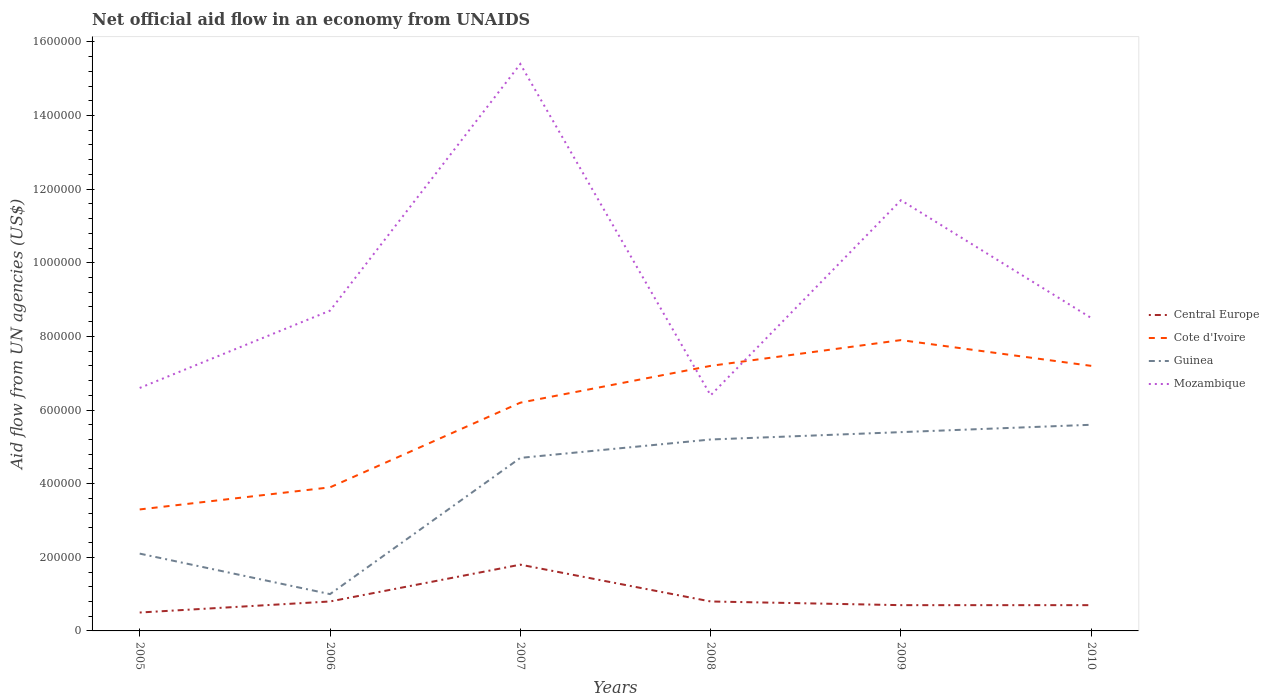Does the line corresponding to Central Europe intersect with the line corresponding to Guinea?
Your answer should be very brief. No. Is the number of lines equal to the number of legend labels?
Your answer should be very brief. Yes. Across all years, what is the maximum net official aid flow in Central Europe?
Your response must be concise. 5.00e+04. In which year was the net official aid flow in Central Europe maximum?
Your response must be concise. 2005. What is the total net official aid flow in Mozambique in the graph?
Your response must be concise. -2.10e+05. What is the difference between the highest and the second highest net official aid flow in Guinea?
Offer a very short reply. 4.60e+05. Is the net official aid flow in Guinea strictly greater than the net official aid flow in Mozambique over the years?
Your answer should be compact. Yes. What is the difference between two consecutive major ticks on the Y-axis?
Your answer should be compact. 2.00e+05. Does the graph contain any zero values?
Provide a succinct answer. No. What is the title of the graph?
Your answer should be compact. Net official aid flow in an economy from UNAIDS. Does "Tanzania" appear as one of the legend labels in the graph?
Provide a succinct answer. No. What is the label or title of the X-axis?
Give a very brief answer. Years. What is the label or title of the Y-axis?
Your answer should be very brief. Aid flow from UN agencies (US$). What is the Aid flow from UN agencies (US$) of Cote d'Ivoire in 2005?
Give a very brief answer. 3.30e+05. What is the Aid flow from UN agencies (US$) in Guinea in 2006?
Provide a short and direct response. 1.00e+05. What is the Aid flow from UN agencies (US$) in Mozambique in 2006?
Make the answer very short. 8.70e+05. What is the Aid flow from UN agencies (US$) of Central Europe in 2007?
Give a very brief answer. 1.80e+05. What is the Aid flow from UN agencies (US$) in Cote d'Ivoire in 2007?
Give a very brief answer. 6.20e+05. What is the Aid flow from UN agencies (US$) of Mozambique in 2007?
Your answer should be very brief. 1.54e+06. What is the Aid flow from UN agencies (US$) in Central Europe in 2008?
Give a very brief answer. 8.00e+04. What is the Aid flow from UN agencies (US$) in Cote d'Ivoire in 2008?
Ensure brevity in your answer.  7.20e+05. What is the Aid flow from UN agencies (US$) of Guinea in 2008?
Your response must be concise. 5.20e+05. What is the Aid flow from UN agencies (US$) in Mozambique in 2008?
Make the answer very short. 6.40e+05. What is the Aid flow from UN agencies (US$) of Cote d'Ivoire in 2009?
Keep it short and to the point. 7.90e+05. What is the Aid flow from UN agencies (US$) in Guinea in 2009?
Your answer should be very brief. 5.40e+05. What is the Aid flow from UN agencies (US$) of Mozambique in 2009?
Offer a terse response. 1.17e+06. What is the Aid flow from UN agencies (US$) in Central Europe in 2010?
Offer a very short reply. 7.00e+04. What is the Aid flow from UN agencies (US$) in Cote d'Ivoire in 2010?
Keep it short and to the point. 7.20e+05. What is the Aid flow from UN agencies (US$) in Guinea in 2010?
Offer a terse response. 5.60e+05. What is the Aid flow from UN agencies (US$) in Mozambique in 2010?
Provide a short and direct response. 8.50e+05. Across all years, what is the maximum Aid flow from UN agencies (US$) of Cote d'Ivoire?
Your response must be concise. 7.90e+05. Across all years, what is the maximum Aid flow from UN agencies (US$) of Guinea?
Your response must be concise. 5.60e+05. Across all years, what is the maximum Aid flow from UN agencies (US$) of Mozambique?
Give a very brief answer. 1.54e+06. Across all years, what is the minimum Aid flow from UN agencies (US$) in Central Europe?
Ensure brevity in your answer.  5.00e+04. Across all years, what is the minimum Aid flow from UN agencies (US$) of Guinea?
Give a very brief answer. 1.00e+05. Across all years, what is the minimum Aid flow from UN agencies (US$) of Mozambique?
Make the answer very short. 6.40e+05. What is the total Aid flow from UN agencies (US$) in Central Europe in the graph?
Your response must be concise. 5.30e+05. What is the total Aid flow from UN agencies (US$) in Cote d'Ivoire in the graph?
Give a very brief answer. 3.57e+06. What is the total Aid flow from UN agencies (US$) in Guinea in the graph?
Make the answer very short. 2.40e+06. What is the total Aid flow from UN agencies (US$) of Mozambique in the graph?
Offer a terse response. 5.73e+06. What is the difference between the Aid flow from UN agencies (US$) in Cote d'Ivoire in 2005 and that in 2006?
Make the answer very short. -6.00e+04. What is the difference between the Aid flow from UN agencies (US$) of Mozambique in 2005 and that in 2006?
Provide a short and direct response. -2.10e+05. What is the difference between the Aid flow from UN agencies (US$) in Cote d'Ivoire in 2005 and that in 2007?
Offer a very short reply. -2.90e+05. What is the difference between the Aid flow from UN agencies (US$) in Guinea in 2005 and that in 2007?
Offer a terse response. -2.60e+05. What is the difference between the Aid flow from UN agencies (US$) of Mozambique in 2005 and that in 2007?
Your answer should be very brief. -8.80e+05. What is the difference between the Aid flow from UN agencies (US$) in Cote d'Ivoire in 2005 and that in 2008?
Your answer should be very brief. -3.90e+05. What is the difference between the Aid flow from UN agencies (US$) of Guinea in 2005 and that in 2008?
Make the answer very short. -3.10e+05. What is the difference between the Aid flow from UN agencies (US$) of Mozambique in 2005 and that in 2008?
Your answer should be very brief. 2.00e+04. What is the difference between the Aid flow from UN agencies (US$) in Central Europe in 2005 and that in 2009?
Your response must be concise. -2.00e+04. What is the difference between the Aid flow from UN agencies (US$) in Cote d'Ivoire in 2005 and that in 2009?
Your answer should be very brief. -4.60e+05. What is the difference between the Aid flow from UN agencies (US$) of Guinea in 2005 and that in 2009?
Your response must be concise. -3.30e+05. What is the difference between the Aid flow from UN agencies (US$) in Mozambique in 2005 and that in 2009?
Your answer should be compact. -5.10e+05. What is the difference between the Aid flow from UN agencies (US$) in Central Europe in 2005 and that in 2010?
Make the answer very short. -2.00e+04. What is the difference between the Aid flow from UN agencies (US$) of Cote d'Ivoire in 2005 and that in 2010?
Your answer should be compact. -3.90e+05. What is the difference between the Aid flow from UN agencies (US$) in Guinea in 2005 and that in 2010?
Make the answer very short. -3.50e+05. What is the difference between the Aid flow from UN agencies (US$) of Mozambique in 2005 and that in 2010?
Your response must be concise. -1.90e+05. What is the difference between the Aid flow from UN agencies (US$) in Central Europe in 2006 and that in 2007?
Provide a succinct answer. -1.00e+05. What is the difference between the Aid flow from UN agencies (US$) of Guinea in 2006 and that in 2007?
Ensure brevity in your answer.  -3.70e+05. What is the difference between the Aid flow from UN agencies (US$) of Mozambique in 2006 and that in 2007?
Provide a succinct answer. -6.70e+05. What is the difference between the Aid flow from UN agencies (US$) of Central Europe in 2006 and that in 2008?
Offer a terse response. 0. What is the difference between the Aid flow from UN agencies (US$) in Cote d'Ivoire in 2006 and that in 2008?
Ensure brevity in your answer.  -3.30e+05. What is the difference between the Aid flow from UN agencies (US$) in Guinea in 2006 and that in 2008?
Offer a very short reply. -4.20e+05. What is the difference between the Aid flow from UN agencies (US$) of Mozambique in 2006 and that in 2008?
Make the answer very short. 2.30e+05. What is the difference between the Aid flow from UN agencies (US$) of Central Europe in 2006 and that in 2009?
Ensure brevity in your answer.  10000. What is the difference between the Aid flow from UN agencies (US$) in Cote d'Ivoire in 2006 and that in 2009?
Ensure brevity in your answer.  -4.00e+05. What is the difference between the Aid flow from UN agencies (US$) of Guinea in 2006 and that in 2009?
Make the answer very short. -4.40e+05. What is the difference between the Aid flow from UN agencies (US$) of Mozambique in 2006 and that in 2009?
Keep it short and to the point. -3.00e+05. What is the difference between the Aid flow from UN agencies (US$) in Cote d'Ivoire in 2006 and that in 2010?
Your response must be concise. -3.30e+05. What is the difference between the Aid flow from UN agencies (US$) in Guinea in 2006 and that in 2010?
Provide a succinct answer. -4.60e+05. What is the difference between the Aid flow from UN agencies (US$) in Central Europe in 2007 and that in 2008?
Give a very brief answer. 1.00e+05. What is the difference between the Aid flow from UN agencies (US$) in Guinea in 2007 and that in 2008?
Provide a short and direct response. -5.00e+04. What is the difference between the Aid flow from UN agencies (US$) in Mozambique in 2007 and that in 2008?
Your answer should be compact. 9.00e+05. What is the difference between the Aid flow from UN agencies (US$) of Cote d'Ivoire in 2007 and that in 2009?
Provide a short and direct response. -1.70e+05. What is the difference between the Aid flow from UN agencies (US$) in Guinea in 2007 and that in 2009?
Give a very brief answer. -7.00e+04. What is the difference between the Aid flow from UN agencies (US$) in Central Europe in 2007 and that in 2010?
Provide a succinct answer. 1.10e+05. What is the difference between the Aid flow from UN agencies (US$) of Cote d'Ivoire in 2007 and that in 2010?
Your answer should be compact. -1.00e+05. What is the difference between the Aid flow from UN agencies (US$) in Guinea in 2007 and that in 2010?
Keep it short and to the point. -9.00e+04. What is the difference between the Aid flow from UN agencies (US$) of Mozambique in 2007 and that in 2010?
Ensure brevity in your answer.  6.90e+05. What is the difference between the Aid flow from UN agencies (US$) of Central Europe in 2008 and that in 2009?
Provide a short and direct response. 10000. What is the difference between the Aid flow from UN agencies (US$) in Cote d'Ivoire in 2008 and that in 2009?
Give a very brief answer. -7.00e+04. What is the difference between the Aid flow from UN agencies (US$) in Mozambique in 2008 and that in 2009?
Your response must be concise. -5.30e+05. What is the difference between the Aid flow from UN agencies (US$) of Central Europe in 2009 and that in 2010?
Keep it short and to the point. 0. What is the difference between the Aid flow from UN agencies (US$) of Cote d'Ivoire in 2009 and that in 2010?
Offer a terse response. 7.00e+04. What is the difference between the Aid flow from UN agencies (US$) in Guinea in 2009 and that in 2010?
Give a very brief answer. -2.00e+04. What is the difference between the Aid flow from UN agencies (US$) in Central Europe in 2005 and the Aid flow from UN agencies (US$) in Cote d'Ivoire in 2006?
Provide a short and direct response. -3.40e+05. What is the difference between the Aid flow from UN agencies (US$) of Central Europe in 2005 and the Aid flow from UN agencies (US$) of Mozambique in 2006?
Your answer should be very brief. -8.20e+05. What is the difference between the Aid flow from UN agencies (US$) of Cote d'Ivoire in 2005 and the Aid flow from UN agencies (US$) of Guinea in 2006?
Your response must be concise. 2.30e+05. What is the difference between the Aid flow from UN agencies (US$) in Cote d'Ivoire in 2005 and the Aid flow from UN agencies (US$) in Mozambique in 2006?
Provide a succinct answer. -5.40e+05. What is the difference between the Aid flow from UN agencies (US$) of Guinea in 2005 and the Aid flow from UN agencies (US$) of Mozambique in 2006?
Offer a terse response. -6.60e+05. What is the difference between the Aid flow from UN agencies (US$) of Central Europe in 2005 and the Aid flow from UN agencies (US$) of Cote d'Ivoire in 2007?
Your answer should be compact. -5.70e+05. What is the difference between the Aid flow from UN agencies (US$) of Central Europe in 2005 and the Aid flow from UN agencies (US$) of Guinea in 2007?
Offer a very short reply. -4.20e+05. What is the difference between the Aid flow from UN agencies (US$) in Central Europe in 2005 and the Aid flow from UN agencies (US$) in Mozambique in 2007?
Provide a short and direct response. -1.49e+06. What is the difference between the Aid flow from UN agencies (US$) in Cote d'Ivoire in 2005 and the Aid flow from UN agencies (US$) in Mozambique in 2007?
Your answer should be very brief. -1.21e+06. What is the difference between the Aid flow from UN agencies (US$) in Guinea in 2005 and the Aid flow from UN agencies (US$) in Mozambique in 2007?
Your response must be concise. -1.33e+06. What is the difference between the Aid flow from UN agencies (US$) of Central Europe in 2005 and the Aid flow from UN agencies (US$) of Cote d'Ivoire in 2008?
Offer a very short reply. -6.70e+05. What is the difference between the Aid flow from UN agencies (US$) of Central Europe in 2005 and the Aid flow from UN agencies (US$) of Guinea in 2008?
Ensure brevity in your answer.  -4.70e+05. What is the difference between the Aid flow from UN agencies (US$) in Central Europe in 2005 and the Aid flow from UN agencies (US$) in Mozambique in 2008?
Give a very brief answer. -5.90e+05. What is the difference between the Aid flow from UN agencies (US$) in Cote d'Ivoire in 2005 and the Aid flow from UN agencies (US$) in Guinea in 2008?
Keep it short and to the point. -1.90e+05. What is the difference between the Aid flow from UN agencies (US$) of Cote d'Ivoire in 2005 and the Aid flow from UN agencies (US$) of Mozambique in 2008?
Ensure brevity in your answer.  -3.10e+05. What is the difference between the Aid flow from UN agencies (US$) of Guinea in 2005 and the Aid flow from UN agencies (US$) of Mozambique in 2008?
Provide a succinct answer. -4.30e+05. What is the difference between the Aid flow from UN agencies (US$) in Central Europe in 2005 and the Aid flow from UN agencies (US$) in Cote d'Ivoire in 2009?
Your answer should be very brief. -7.40e+05. What is the difference between the Aid flow from UN agencies (US$) in Central Europe in 2005 and the Aid flow from UN agencies (US$) in Guinea in 2009?
Your response must be concise. -4.90e+05. What is the difference between the Aid flow from UN agencies (US$) in Central Europe in 2005 and the Aid flow from UN agencies (US$) in Mozambique in 2009?
Offer a terse response. -1.12e+06. What is the difference between the Aid flow from UN agencies (US$) of Cote d'Ivoire in 2005 and the Aid flow from UN agencies (US$) of Guinea in 2009?
Make the answer very short. -2.10e+05. What is the difference between the Aid flow from UN agencies (US$) in Cote d'Ivoire in 2005 and the Aid flow from UN agencies (US$) in Mozambique in 2009?
Give a very brief answer. -8.40e+05. What is the difference between the Aid flow from UN agencies (US$) in Guinea in 2005 and the Aid flow from UN agencies (US$) in Mozambique in 2009?
Offer a terse response. -9.60e+05. What is the difference between the Aid flow from UN agencies (US$) in Central Europe in 2005 and the Aid flow from UN agencies (US$) in Cote d'Ivoire in 2010?
Give a very brief answer. -6.70e+05. What is the difference between the Aid flow from UN agencies (US$) in Central Europe in 2005 and the Aid flow from UN agencies (US$) in Guinea in 2010?
Your response must be concise. -5.10e+05. What is the difference between the Aid flow from UN agencies (US$) of Central Europe in 2005 and the Aid flow from UN agencies (US$) of Mozambique in 2010?
Make the answer very short. -8.00e+05. What is the difference between the Aid flow from UN agencies (US$) in Cote d'Ivoire in 2005 and the Aid flow from UN agencies (US$) in Guinea in 2010?
Your answer should be very brief. -2.30e+05. What is the difference between the Aid flow from UN agencies (US$) of Cote d'Ivoire in 2005 and the Aid flow from UN agencies (US$) of Mozambique in 2010?
Give a very brief answer. -5.20e+05. What is the difference between the Aid flow from UN agencies (US$) of Guinea in 2005 and the Aid flow from UN agencies (US$) of Mozambique in 2010?
Ensure brevity in your answer.  -6.40e+05. What is the difference between the Aid flow from UN agencies (US$) of Central Europe in 2006 and the Aid flow from UN agencies (US$) of Cote d'Ivoire in 2007?
Ensure brevity in your answer.  -5.40e+05. What is the difference between the Aid flow from UN agencies (US$) in Central Europe in 2006 and the Aid flow from UN agencies (US$) in Guinea in 2007?
Your answer should be compact. -3.90e+05. What is the difference between the Aid flow from UN agencies (US$) of Central Europe in 2006 and the Aid flow from UN agencies (US$) of Mozambique in 2007?
Offer a very short reply. -1.46e+06. What is the difference between the Aid flow from UN agencies (US$) in Cote d'Ivoire in 2006 and the Aid flow from UN agencies (US$) in Guinea in 2007?
Your response must be concise. -8.00e+04. What is the difference between the Aid flow from UN agencies (US$) of Cote d'Ivoire in 2006 and the Aid flow from UN agencies (US$) of Mozambique in 2007?
Your answer should be compact. -1.15e+06. What is the difference between the Aid flow from UN agencies (US$) of Guinea in 2006 and the Aid flow from UN agencies (US$) of Mozambique in 2007?
Offer a terse response. -1.44e+06. What is the difference between the Aid flow from UN agencies (US$) of Central Europe in 2006 and the Aid flow from UN agencies (US$) of Cote d'Ivoire in 2008?
Offer a very short reply. -6.40e+05. What is the difference between the Aid flow from UN agencies (US$) in Central Europe in 2006 and the Aid flow from UN agencies (US$) in Guinea in 2008?
Your answer should be very brief. -4.40e+05. What is the difference between the Aid flow from UN agencies (US$) in Central Europe in 2006 and the Aid flow from UN agencies (US$) in Mozambique in 2008?
Provide a short and direct response. -5.60e+05. What is the difference between the Aid flow from UN agencies (US$) of Cote d'Ivoire in 2006 and the Aid flow from UN agencies (US$) of Guinea in 2008?
Your response must be concise. -1.30e+05. What is the difference between the Aid flow from UN agencies (US$) of Cote d'Ivoire in 2006 and the Aid flow from UN agencies (US$) of Mozambique in 2008?
Give a very brief answer. -2.50e+05. What is the difference between the Aid flow from UN agencies (US$) of Guinea in 2006 and the Aid flow from UN agencies (US$) of Mozambique in 2008?
Keep it short and to the point. -5.40e+05. What is the difference between the Aid flow from UN agencies (US$) of Central Europe in 2006 and the Aid flow from UN agencies (US$) of Cote d'Ivoire in 2009?
Provide a succinct answer. -7.10e+05. What is the difference between the Aid flow from UN agencies (US$) in Central Europe in 2006 and the Aid flow from UN agencies (US$) in Guinea in 2009?
Ensure brevity in your answer.  -4.60e+05. What is the difference between the Aid flow from UN agencies (US$) in Central Europe in 2006 and the Aid flow from UN agencies (US$) in Mozambique in 2009?
Provide a short and direct response. -1.09e+06. What is the difference between the Aid flow from UN agencies (US$) in Cote d'Ivoire in 2006 and the Aid flow from UN agencies (US$) in Mozambique in 2009?
Provide a succinct answer. -7.80e+05. What is the difference between the Aid flow from UN agencies (US$) of Guinea in 2006 and the Aid flow from UN agencies (US$) of Mozambique in 2009?
Keep it short and to the point. -1.07e+06. What is the difference between the Aid flow from UN agencies (US$) in Central Europe in 2006 and the Aid flow from UN agencies (US$) in Cote d'Ivoire in 2010?
Provide a succinct answer. -6.40e+05. What is the difference between the Aid flow from UN agencies (US$) of Central Europe in 2006 and the Aid flow from UN agencies (US$) of Guinea in 2010?
Your answer should be very brief. -4.80e+05. What is the difference between the Aid flow from UN agencies (US$) in Central Europe in 2006 and the Aid flow from UN agencies (US$) in Mozambique in 2010?
Provide a succinct answer. -7.70e+05. What is the difference between the Aid flow from UN agencies (US$) in Cote d'Ivoire in 2006 and the Aid flow from UN agencies (US$) in Mozambique in 2010?
Keep it short and to the point. -4.60e+05. What is the difference between the Aid flow from UN agencies (US$) of Guinea in 2006 and the Aid flow from UN agencies (US$) of Mozambique in 2010?
Provide a short and direct response. -7.50e+05. What is the difference between the Aid flow from UN agencies (US$) of Central Europe in 2007 and the Aid flow from UN agencies (US$) of Cote d'Ivoire in 2008?
Your answer should be compact. -5.40e+05. What is the difference between the Aid flow from UN agencies (US$) in Central Europe in 2007 and the Aid flow from UN agencies (US$) in Mozambique in 2008?
Make the answer very short. -4.60e+05. What is the difference between the Aid flow from UN agencies (US$) in Cote d'Ivoire in 2007 and the Aid flow from UN agencies (US$) in Guinea in 2008?
Provide a succinct answer. 1.00e+05. What is the difference between the Aid flow from UN agencies (US$) in Cote d'Ivoire in 2007 and the Aid flow from UN agencies (US$) in Mozambique in 2008?
Make the answer very short. -2.00e+04. What is the difference between the Aid flow from UN agencies (US$) in Central Europe in 2007 and the Aid flow from UN agencies (US$) in Cote d'Ivoire in 2009?
Provide a short and direct response. -6.10e+05. What is the difference between the Aid flow from UN agencies (US$) in Central Europe in 2007 and the Aid flow from UN agencies (US$) in Guinea in 2009?
Give a very brief answer. -3.60e+05. What is the difference between the Aid flow from UN agencies (US$) in Central Europe in 2007 and the Aid flow from UN agencies (US$) in Mozambique in 2009?
Offer a very short reply. -9.90e+05. What is the difference between the Aid flow from UN agencies (US$) in Cote d'Ivoire in 2007 and the Aid flow from UN agencies (US$) in Guinea in 2009?
Offer a very short reply. 8.00e+04. What is the difference between the Aid flow from UN agencies (US$) in Cote d'Ivoire in 2007 and the Aid flow from UN agencies (US$) in Mozambique in 2009?
Offer a very short reply. -5.50e+05. What is the difference between the Aid flow from UN agencies (US$) of Guinea in 2007 and the Aid flow from UN agencies (US$) of Mozambique in 2009?
Provide a succinct answer. -7.00e+05. What is the difference between the Aid flow from UN agencies (US$) of Central Europe in 2007 and the Aid flow from UN agencies (US$) of Cote d'Ivoire in 2010?
Keep it short and to the point. -5.40e+05. What is the difference between the Aid flow from UN agencies (US$) of Central Europe in 2007 and the Aid flow from UN agencies (US$) of Guinea in 2010?
Offer a terse response. -3.80e+05. What is the difference between the Aid flow from UN agencies (US$) in Central Europe in 2007 and the Aid flow from UN agencies (US$) in Mozambique in 2010?
Your answer should be compact. -6.70e+05. What is the difference between the Aid flow from UN agencies (US$) of Cote d'Ivoire in 2007 and the Aid flow from UN agencies (US$) of Guinea in 2010?
Provide a succinct answer. 6.00e+04. What is the difference between the Aid flow from UN agencies (US$) in Cote d'Ivoire in 2007 and the Aid flow from UN agencies (US$) in Mozambique in 2010?
Provide a short and direct response. -2.30e+05. What is the difference between the Aid flow from UN agencies (US$) in Guinea in 2007 and the Aid flow from UN agencies (US$) in Mozambique in 2010?
Offer a very short reply. -3.80e+05. What is the difference between the Aid flow from UN agencies (US$) in Central Europe in 2008 and the Aid flow from UN agencies (US$) in Cote d'Ivoire in 2009?
Provide a short and direct response. -7.10e+05. What is the difference between the Aid flow from UN agencies (US$) in Central Europe in 2008 and the Aid flow from UN agencies (US$) in Guinea in 2009?
Provide a succinct answer. -4.60e+05. What is the difference between the Aid flow from UN agencies (US$) in Central Europe in 2008 and the Aid flow from UN agencies (US$) in Mozambique in 2009?
Offer a very short reply. -1.09e+06. What is the difference between the Aid flow from UN agencies (US$) in Cote d'Ivoire in 2008 and the Aid flow from UN agencies (US$) in Guinea in 2009?
Offer a terse response. 1.80e+05. What is the difference between the Aid flow from UN agencies (US$) in Cote d'Ivoire in 2008 and the Aid flow from UN agencies (US$) in Mozambique in 2009?
Provide a succinct answer. -4.50e+05. What is the difference between the Aid flow from UN agencies (US$) of Guinea in 2008 and the Aid flow from UN agencies (US$) of Mozambique in 2009?
Provide a succinct answer. -6.50e+05. What is the difference between the Aid flow from UN agencies (US$) in Central Europe in 2008 and the Aid flow from UN agencies (US$) in Cote d'Ivoire in 2010?
Provide a succinct answer. -6.40e+05. What is the difference between the Aid flow from UN agencies (US$) of Central Europe in 2008 and the Aid flow from UN agencies (US$) of Guinea in 2010?
Your response must be concise. -4.80e+05. What is the difference between the Aid flow from UN agencies (US$) in Central Europe in 2008 and the Aid flow from UN agencies (US$) in Mozambique in 2010?
Provide a short and direct response. -7.70e+05. What is the difference between the Aid flow from UN agencies (US$) in Cote d'Ivoire in 2008 and the Aid flow from UN agencies (US$) in Guinea in 2010?
Provide a succinct answer. 1.60e+05. What is the difference between the Aid flow from UN agencies (US$) in Guinea in 2008 and the Aid flow from UN agencies (US$) in Mozambique in 2010?
Offer a terse response. -3.30e+05. What is the difference between the Aid flow from UN agencies (US$) of Central Europe in 2009 and the Aid flow from UN agencies (US$) of Cote d'Ivoire in 2010?
Keep it short and to the point. -6.50e+05. What is the difference between the Aid flow from UN agencies (US$) in Central Europe in 2009 and the Aid flow from UN agencies (US$) in Guinea in 2010?
Make the answer very short. -4.90e+05. What is the difference between the Aid flow from UN agencies (US$) in Central Europe in 2009 and the Aid flow from UN agencies (US$) in Mozambique in 2010?
Your response must be concise. -7.80e+05. What is the difference between the Aid flow from UN agencies (US$) in Cote d'Ivoire in 2009 and the Aid flow from UN agencies (US$) in Guinea in 2010?
Provide a succinct answer. 2.30e+05. What is the difference between the Aid flow from UN agencies (US$) in Cote d'Ivoire in 2009 and the Aid flow from UN agencies (US$) in Mozambique in 2010?
Your response must be concise. -6.00e+04. What is the difference between the Aid flow from UN agencies (US$) in Guinea in 2009 and the Aid flow from UN agencies (US$) in Mozambique in 2010?
Offer a terse response. -3.10e+05. What is the average Aid flow from UN agencies (US$) of Central Europe per year?
Your answer should be compact. 8.83e+04. What is the average Aid flow from UN agencies (US$) in Cote d'Ivoire per year?
Ensure brevity in your answer.  5.95e+05. What is the average Aid flow from UN agencies (US$) in Guinea per year?
Offer a very short reply. 4.00e+05. What is the average Aid flow from UN agencies (US$) of Mozambique per year?
Your answer should be very brief. 9.55e+05. In the year 2005, what is the difference between the Aid flow from UN agencies (US$) in Central Europe and Aid flow from UN agencies (US$) in Cote d'Ivoire?
Give a very brief answer. -2.80e+05. In the year 2005, what is the difference between the Aid flow from UN agencies (US$) in Central Europe and Aid flow from UN agencies (US$) in Guinea?
Offer a very short reply. -1.60e+05. In the year 2005, what is the difference between the Aid flow from UN agencies (US$) of Central Europe and Aid flow from UN agencies (US$) of Mozambique?
Offer a very short reply. -6.10e+05. In the year 2005, what is the difference between the Aid flow from UN agencies (US$) of Cote d'Ivoire and Aid flow from UN agencies (US$) of Guinea?
Give a very brief answer. 1.20e+05. In the year 2005, what is the difference between the Aid flow from UN agencies (US$) in Cote d'Ivoire and Aid flow from UN agencies (US$) in Mozambique?
Make the answer very short. -3.30e+05. In the year 2005, what is the difference between the Aid flow from UN agencies (US$) in Guinea and Aid flow from UN agencies (US$) in Mozambique?
Ensure brevity in your answer.  -4.50e+05. In the year 2006, what is the difference between the Aid flow from UN agencies (US$) in Central Europe and Aid flow from UN agencies (US$) in Cote d'Ivoire?
Your answer should be very brief. -3.10e+05. In the year 2006, what is the difference between the Aid flow from UN agencies (US$) of Central Europe and Aid flow from UN agencies (US$) of Guinea?
Make the answer very short. -2.00e+04. In the year 2006, what is the difference between the Aid flow from UN agencies (US$) in Central Europe and Aid flow from UN agencies (US$) in Mozambique?
Make the answer very short. -7.90e+05. In the year 2006, what is the difference between the Aid flow from UN agencies (US$) in Cote d'Ivoire and Aid flow from UN agencies (US$) in Mozambique?
Your answer should be compact. -4.80e+05. In the year 2006, what is the difference between the Aid flow from UN agencies (US$) of Guinea and Aid flow from UN agencies (US$) of Mozambique?
Provide a short and direct response. -7.70e+05. In the year 2007, what is the difference between the Aid flow from UN agencies (US$) of Central Europe and Aid flow from UN agencies (US$) of Cote d'Ivoire?
Make the answer very short. -4.40e+05. In the year 2007, what is the difference between the Aid flow from UN agencies (US$) in Central Europe and Aid flow from UN agencies (US$) in Mozambique?
Your answer should be compact. -1.36e+06. In the year 2007, what is the difference between the Aid flow from UN agencies (US$) in Cote d'Ivoire and Aid flow from UN agencies (US$) in Guinea?
Offer a very short reply. 1.50e+05. In the year 2007, what is the difference between the Aid flow from UN agencies (US$) in Cote d'Ivoire and Aid flow from UN agencies (US$) in Mozambique?
Make the answer very short. -9.20e+05. In the year 2007, what is the difference between the Aid flow from UN agencies (US$) in Guinea and Aid flow from UN agencies (US$) in Mozambique?
Keep it short and to the point. -1.07e+06. In the year 2008, what is the difference between the Aid flow from UN agencies (US$) of Central Europe and Aid flow from UN agencies (US$) of Cote d'Ivoire?
Keep it short and to the point. -6.40e+05. In the year 2008, what is the difference between the Aid flow from UN agencies (US$) in Central Europe and Aid flow from UN agencies (US$) in Guinea?
Provide a short and direct response. -4.40e+05. In the year 2008, what is the difference between the Aid flow from UN agencies (US$) in Central Europe and Aid flow from UN agencies (US$) in Mozambique?
Your answer should be very brief. -5.60e+05. In the year 2008, what is the difference between the Aid flow from UN agencies (US$) of Guinea and Aid flow from UN agencies (US$) of Mozambique?
Ensure brevity in your answer.  -1.20e+05. In the year 2009, what is the difference between the Aid flow from UN agencies (US$) of Central Europe and Aid flow from UN agencies (US$) of Cote d'Ivoire?
Offer a terse response. -7.20e+05. In the year 2009, what is the difference between the Aid flow from UN agencies (US$) in Central Europe and Aid flow from UN agencies (US$) in Guinea?
Your answer should be compact. -4.70e+05. In the year 2009, what is the difference between the Aid flow from UN agencies (US$) in Central Europe and Aid flow from UN agencies (US$) in Mozambique?
Give a very brief answer. -1.10e+06. In the year 2009, what is the difference between the Aid flow from UN agencies (US$) in Cote d'Ivoire and Aid flow from UN agencies (US$) in Guinea?
Your answer should be compact. 2.50e+05. In the year 2009, what is the difference between the Aid flow from UN agencies (US$) of Cote d'Ivoire and Aid flow from UN agencies (US$) of Mozambique?
Make the answer very short. -3.80e+05. In the year 2009, what is the difference between the Aid flow from UN agencies (US$) in Guinea and Aid flow from UN agencies (US$) in Mozambique?
Make the answer very short. -6.30e+05. In the year 2010, what is the difference between the Aid flow from UN agencies (US$) in Central Europe and Aid flow from UN agencies (US$) in Cote d'Ivoire?
Ensure brevity in your answer.  -6.50e+05. In the year 2010, what is the difference between the Aid flow from UN agencies (US$) of Central Europe and Aid flow from UN agencies (US$) of Guinea?
Make the answer very short. -4.90e+05. In the year 2010, what is the difference between the Aid flow from UN agencies (US$) of Central Europe and Aid flow from UN agencies (US$) of Mozambique?
Provide a short and direct response. -7.80e+05. In the year 2010, what is the difference between the Aid flow from UN agencies (US$) in Cote d'Ivoire and Aid flow from UN agencies (US$) in Mozambique?
Offer a very short reply. -1.30e+05. What is the ratio of the Aid flow from UN agencies (US$) in Cote d'Ivoire in 2005 to that in 2006?
Give a very brief answer. 0.85. What is the ratio of the Aid flow from UN agencies (US$) of Mozambique in 2005 to that in 2006?
Your response must be concise. 0.76. What is the ratio of the Aid flow from UN agencies (US$) in Central Europe in 2005 to that in 2007?
Make the answer very short. 0.28. What is the ratio of the Aid flow from UN agencies (US$) in Cote d'Ivoire in 2005 to that in 2007?
Give a very brief answer. 0.53. What is the ratio of the Aid flow from UN agencies (US$) of Guinea in 2005 to that in 2007?
Offer a terse response. 0.45. What is the ratio of the Aid flow from UN agencies (US$) of Mozambique in 2005 to that in 2007?
Provide a succinct answer. 0.43. What is the ratio of the Aid flow from UN agencies (US$) in Central Europe in 2005 to that in 2008?
Offer a terse response. 0.62. What is the ratio of the Aid flow from UN agencies (US$) of Cote d'Ivoire in 2005 to that in 2008?
Keep it short and to the point. 0.46. What is the ratio of the Aid flow from UN agencies (US$) of Guinea in 2005 to that in 2008?
Provide a short and direct response. 0.4. What is the ratio of the Aid flow from UN agencies (US$) of Mozambique in 2005 to that in 2008?
Offer a very short reply. 1.03. What is the ratio of the Aid flow from UN agencies (US$) of Central Europe in 2005 to that in 2009?
Ensure brevity in your answer.  0.71. What is the ratio of the Aid flow from UN agencies (US$) in Cote d'Ivoire in 2005 to that in 2009?
Provide a succinct answer. 0.42. What is the ratio of the Aid flow from UN agencies (US$) in Guinea in 2005 to that in 2009?
Offer a very short reply. 0.39. What is the ratio of the Aid flow from UN agencies (US$) of Mozambique in 2005 to that in 2009?
Provide a short and direct response. 0.56. What is the ratio of the Aid flow from UN agencies (US$) of Central Europe in 2005 to that in 2010?
Keep it short and to the point. 0.71. What is the ratio of the Aid flow from UN agencies (US$) of Cote d'Ivoire in 2005 to that in 2010?
Keep it short and to the point. 0.46. What is the ratio of the Aid flow from UN agencies (US$) in Mozambique in 2005 to that in 2010?
Ensure brevity in your answer.  0.78. What is the ratio of the Aid flow from UN agencies (US$) in Central Europe in 2006 to that in 2007?
Make the answer very short. 0.44. What is the ratio of the Aid flow from UN agencies (US$) of Cote d'Ivoire in 2006 to that in 2007?
Your response must be concise. 0.63. What is the ratio of the Aid flow from UN agencies (US$) in Guinea in 2006 to that in 2007?
Offer a very short reply. 0.21. What is the ratio of the Aid flow from UN agencies (US$) in Mozambique in 2006 to that in 2007?
Your answer should be very brief. 0.56. What is the ratio of the Aid flow from UN agencies (US$) of Central Europe in 2006 to that in 2008?
Make the answer very short. 1. What is the ratio of the Aid flow from UN agencies (US$) of Cote d'Ivoire in 2006 to that in 2008?
Provide a short and direct response. 0.54. What is the ratio of the Aid flow from UN agencies (US$) in Guinea in 2006 to that in 2008?
Give a very brief answer. 0.19. What is the ratio of the Aid flow from UN agencies (US$) of Mozambique in 2006 to that in 2008?
Give a very brief answer. 1.36. What is the ratio of the Aid flow from UN agencies (US$) of Cote d'Ivoire in 2006 to that in 2009?
Ensure brevity in your answer.  0.49. What is the ratio of the Aid flow from UN agencies (US$) of Guinea in 2006 to that in 2009?
Give a very brief answer. 0.19. What is the ratio of the Aid flow from UN agencies (US$) of Mozambique in 2006 to that in 2009?
Keep it short and to the point. 0.74. What is the ratio of the Aid flow from UN agencies (US$) in Cote d'Ivoire in 2006 to that in 2010?
Give a very brief answer. 0.54. What is the ratio of the Aid flow from UN agencies (US$) in Guinea in 2006 to that in 2010?
Give a very brief answer. 0.18. What is the ratio of the Aid flow from UN agencies (US$) in Mozambique in 2006 to that in 2010?
Your answer should be very brief. 1.02. What is the ratio of the Aid flow from UN agencies (US$) in Central Europe in 2007 to that in 2008?
Your answer should be very brief. 2.25. What is the ratio of the Aid flow from UN agencies (US$) in Cote d'Ivoire in 2007 to that in 2008?
Your answer should be very brief. 0.86. What is the ratio of the Aid flow from UN agencies (US$) in Guinea in 2007 to that in 2008?
Your response must be concise. 0.9. What is the ratio of the Aid flow from UN agencies (US$) of Mozambique in 2007 to that in 2008?
Offer a terse response. 2.41. What is the ratio of the Aid flow from UN agencies (US$) in Central Europe in 2007 to that in 2009?
Your answer should be very brief. 2.57. What is the ratio of the Aid flow from UN agencies (US$) in Cote d'Ivoire in 2007 to that in 2009?
Your answer should be very brief. 0.78. What is the ratio of the Aid flow from UN agencies (US$) of Guinea in 2007 to that in 2009?
Your response must be concise. 0.87. What is the ratio of the Aid flow from UN agencies (US$) of Mozambique in 2007 to that in 2009?
Your answer should be compact. 1.32. What is the ratio of the Aid flow from UN agencies (US$) in Central Europe in 2007 to that in 2010?
Offer a terse response. 2.57. What is the ratio of the Aid flow from UN agencies (US$) of Cote d'Ivoire in 2007 to that in 2010?
Ensure brevity in your answer.  0.86. What is the ratio of the Aid flow from UN agencies (US$) in Guinea in 2007 to that in 2010?
Provide a succinct answer. 0.84. What is the ratio of the Aid flow from UN agencies (US$) in Mozambique in 2007 to that in 2010?
Keep it short and to the point. 1.81. What is the ratio of the Aid flow from UN agencies (US$) in Cote d'Ivoire in 2008 to that in 2009?
Keep it short and to the point. 0.91. What is the ratio of the Aid flow from UN agencies (US$) in Mozambique in 2008 to that in 2009?
Your answer should be compact. 0.55. What is the ratio of the Aid flow from UN agencies (US$) of Cote d'Ivoire in 2008 to that in 2010?
Offer a very short reply. 1. What is the ratio of the Aid flow from UN agencies (US$) of Guinea in 2008 to that in 2010?
Your response must be concise. 0.93. What is the ratio of the Aid flow from UN agencies (US$) of Mozambique in 2008 to that in 2010?
Ensure brevity in your answer.  0.75. What is the ratio of the Aid flow from UN agencies (US$) in Central Europe in 2009 to that in 2010?
Keep it short and to the point. 1. What is the ratio of the Aid flow from UN agencies (US$) of Cote d'Ivoire in 2009 to that in 2010?
Give a very brief answer. 1.1. What is the ratio of the Aid flow from UN agencies (US$) of Guinea in 2009 to that in 2010?
Provide a succinct answer. 0.96. What is the ratio of the Aid flow from UN agencies (US$) in Mozambique in 2009 to that in 2010?
Your response must be concise. 1.38. What is the difference between the highest and the second highest Aid flow from UN agencies (US$) of Central Europe?
Your response must be concise. 1.00e+05. What is the difference between the highest and the second highest Aid flow from UN agencies (US$) of Guinea?
Provide a short and direct response. 2.00e+04. What is the difference between the highest and the lowest Aid flow from UN agencies (US$) in Cote d'Ivoire?
Your answer should be very brief. 4.60e+05. What is the difference between the highest and the lowest Aid flow from UN agencies (US$) of Mozambique?
Your answer should be compact. 9.00e+05. 